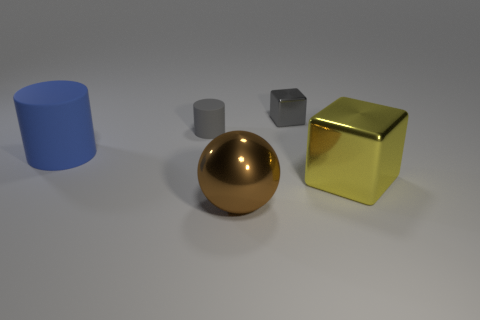Add 2 brown shiny spheres. How many objects exist? 7 Subtract all blocks. How many objects are left? 3 Add 1 tiny gray objects. How many tiny gray objects exist? 3 Subtract 1 gray blocks. How many objects are left? 4 Subtract all small shiny objects. Subtract all large brown metal spheres. How many objects are left? 3 Add 4 tiny gray things. How many tiny gray things are left? 6 